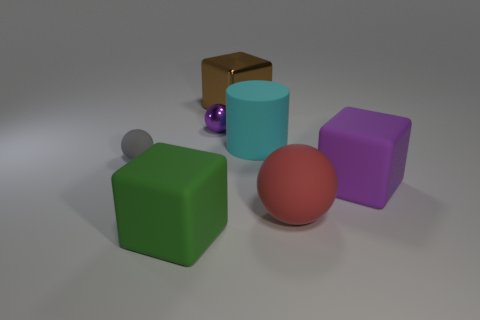What number of spheres are both in front of the tiny gray thing and left of the brown cube?
Offer a terse response. 0. There is a big cube that is in front of the matte ball that is in front of the big purple rubber thing; what is it made of?
Your answer should be compact. Rubber. Is there another large red object that has the same material as the red thing?
Provide a short and direct response. No. There is a brown object that is the same size as the purple rubber block; what is its material?
Keep it short and to the point. Metal. What is the size of the rubber cube that is behind the big matte thing left of the purple thing left of the cyan matte thing?
Give a very brief answer. Large. There is a large block on the left side of the tiny purple metallic object; are there any green matte objects behind it?
Ensure brevity in your answer.  No. Do the gray thing and the purple thing that is on the right side of the big cyan matte thing have the same shape?
Your answer should be compact. No. There is a big matte ball that is on the right side of the big brown object; what color is it?
Your answer should be very brief. Red. What is the size of the block that is behind the matte block right of the green matte thing?
Offer a very short reply. Large. There is a purple object that is on the left side of the large purple matte thing; is it the same shape as the red matte thing?
Keep it short and to the point. Yes. 